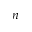<formula> <loc_0><loc_0><loc_500><loc_500>n</formula> 